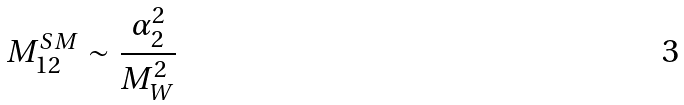Convert formula to latex. <formula><loc_0><loc_0><loc_500><loc_500>M _ { 1 2 } ^ { S M } \sim \frac { \alpha _ { 2 } ^ { 2 } } { M _ { W } ^ { 2 } }</formula> 